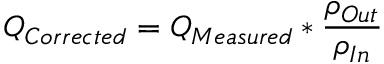Convert formula to latex. <formula><loc_0><loc_0><loc_500><loc_500>Q _ { C o r r e c t e d } = Q _ { M e a s u r e d } * { \frac { \rho _ { O u t } } { \rho _ { I n } } } \,</formula> 